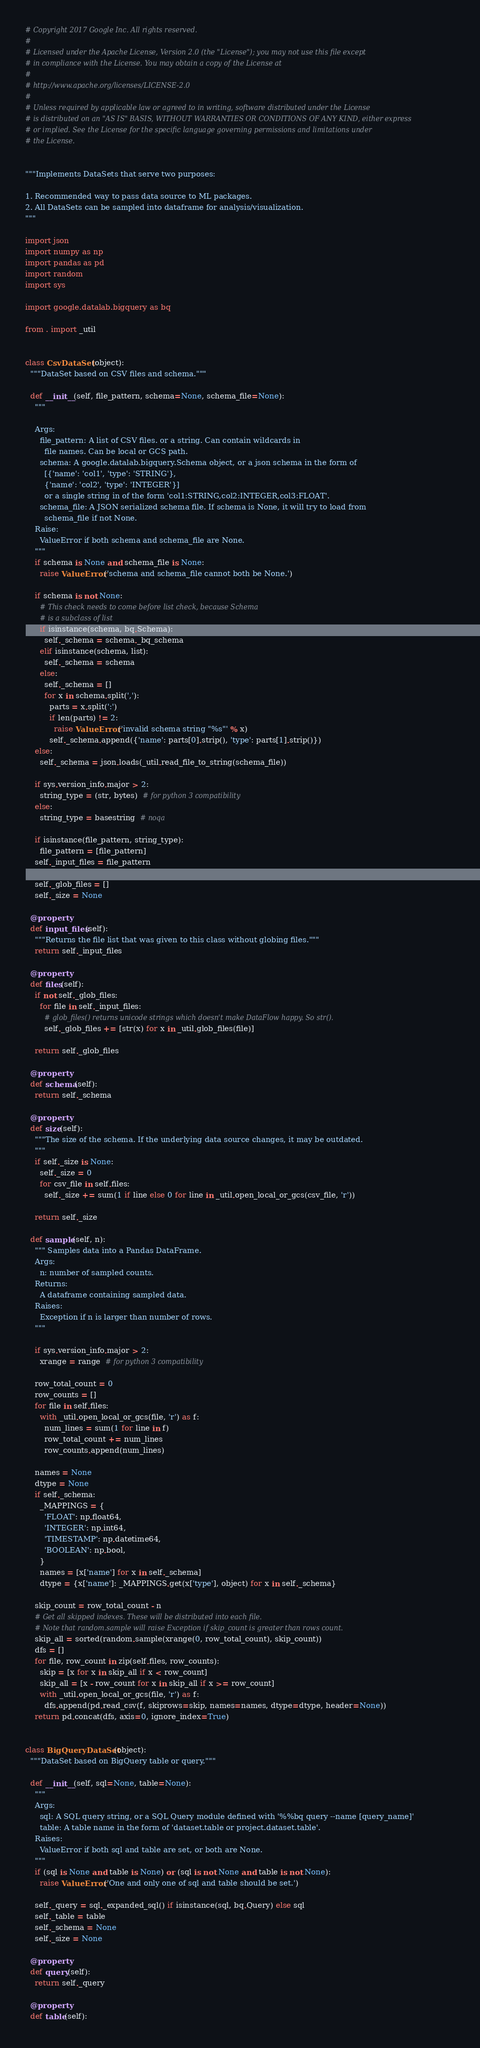Convert code to text. <code><loc_0><loc_0><loc_500><loc_500><_Python_># Copyright 2017 Google Inc. All rights reserved.
#
# Licensed under the Apache License, Version 2.0 (the "License"); you may not use this file except
# in compliance with the License. You may obtain a copy of the License at
#
# http://www.apache.org/licenses/LICENSE-2.0
#
# Unless required by applicable law or agreed to in writing, software distributed under the License
# is distributed on an "AS IS" BASIS, WITHOUT WARRANTIES OR CONDITIONS OF ANY KIND, either express
# or implied. See the License for the specific language governing permissions and limitations under
# the License.


"""Implements DataSets that serve two purposes:

1. Recommended way to pass data source to ML packages.
2. All DataSets can be sampled into dataframe for analysis/visualization.
"""

import json
import numpy as np
import pandas as pd
import random
import sys

import google.datalab.bigquery as bq

from . import _util


class CsvDataSet(object):
  """DataSet based on CSV files and schema."""

  def __init__(self, file_pattern, schema=None, schema_file=None):
    """

    Args:
      file_pattern: A list of CSV files. or a string. Can contain wildcards in
        file names. Can be local or GCS path.
      schema: A google.datalab.bigquery.Schema object, or a json schema in the form of
        [{'name': 'col1', 'type': 'STRING'},
        {'name': 'col2', 'type': 'INTEGER'}]
        or a single string in of the form 'col1:STRING,col2:INTEGER,col3:FLOAT'.
      schema_file: A JSON serialized schema file. If schema is None, it will try to load from
        schema_file if not None.
    Raise:
      ValueError if both schema and schema_file are None.
    """
    if schema is None and schema_file is None:
      raise ValueError('schema and schema_file cannot both be None.')

    if schema is not None:
      # This check needs to come before list check, because Schema
      # is a subclass of list
      if isinstance(schema, bq.Schema):
        self._schema = schema._bq_schema
      elif isinstance(schema, list):
        self._schema = schema
      else:
        self._schema = []
        for x in schema.split(','):
          parts = x.split(':')
          if len(parts) != 2:
            raise ValueError('invalid schema string "%s"' % x)
          self._schema.append({'name': parts[0].strip(), 'type': parts[1].strip()})
    else:
      self._schema = json.loads(_util.read_file_to_string(schema_file))

    if sys.version_info.major > 2:
      string_type = (str, bytes)  # for python 3 compatibility
    else:
      string_type = basestring  # noqa

    if isinstance(file_pattern, string_type):
      file_pattern = [file_pattern]
    self._input_files = file_pattern

    self._glob_files = []
    self._size = None

  @property
  def input_files(self):
    """Returns the file list that was given to this class without globing files."""
    return self._input_files

  @property
  def files(self):
    if not self._glob_files:
      for file in self._input_files:
        # glob_files() returns unicode strings which doesn't make DataFlow happy. So str().
        self._glob_files += [str(x) for x in _util.glob_files(file)]

    return self._glob_files

  @property
  def schema(self):
    return self._schema

  @property
  def size(self):
    """The size of the schema. If the underlying data source changes, it may be outdated.
    """
    if self._size is None:
      self._size = 0
      for csv_file in self.files:
        self._size += sum(1 if line else 0 for line in _util.open_local_or_gcs(csv_file, 'r'))

    return self._size

  def sample(self, n):
    """ Samples data into a Pandas DataFrame.
    Args:
      n: number of sampled counts.
    Returns:
      A dataframe containing sampled data.
    Raises:
      Exception if n is larger than number of rows.
    """

    if sys.version_info.major > 2:
      xrange = range  # for python 3 compatibility

    row_total_count = 0
    row_counts = []
    for file in self.files:
      with _util.open_local_or_gcs(file, 'r') as f:
        num_lines = sum(1 for line in f)
        row_total_count += num_lines
        row_counts.append(num_lines)

    names = None
    dtype = None
    if self._schema:
      _MAPPINGS = {
        'FLOAT': np.float64,
        'INTEGER': np.int64,
        'TIMESTAMP': np.datetime64,
        'BOOLEAN': np.bool,
      }
      names = [x['name'] for x in self._schema]
      dtype = {x['name']: _MAPPINGS.get(x['type'], object) for x in self._schema}

    skip_count = row_total_count - n
    # Get all skipped indexes. These will be distributed into each file.
    # Note that random.sample will raise Exception if skip_count is greater than rows count.
    skip_all = sorted(random.sample(xrange(0, row_total_count), skip_count))
    dfs = []
    for file, row_count in zip(self.files, row_counts):
      skip = [x for x in skip_all if x < row_count]
      skip_all = [x - row_count for x in skip_all if x >= row_count]
      with _util.open_local_or_gcs(file, 'r') as f:
        dfs.append(pd.read_csv(f, skiprows=skip, names=names, dtype=dtype, header=None))
    return pd.concat(dfs, axis=0, ignore_index=True)


class BigQueryDataSet(object):
  """DataSet based on BigQuery table or query."""

  def __init__(self, sql=None, table=None):
    """
    Args:
      sql: A SQL query string, or a SQL Query module defined with '%%bq query --name [query_name]'
      table: A table name in the form of 'dataset.table or project.dataset.table'.
    Raises:
      ValueError if both sql and table are set, or both are None.
    """
    if (sql is None and table is None) or (sql is not None and table is not None):
      raise ValueError('One and only one of sql and table should be set.')

    self._query = sql._expanded_sql() if isinstance(sql, bq.Query) else sql
    self._table = table
    self._schema = None
    self._size = None

  @property
  def query(self):
    return self._query

  @property
  def table(self):</code> 